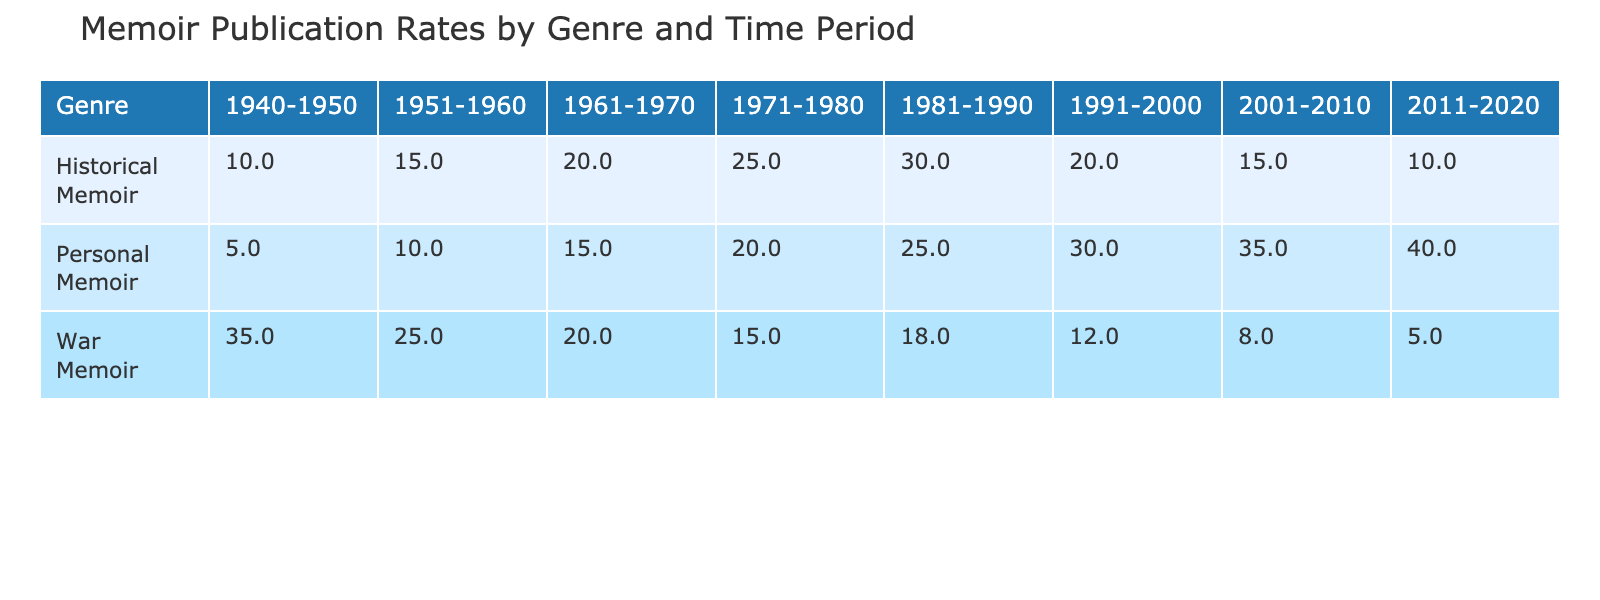What was the publication rate for War Memoirs in the 1940-1950 time period? The table shows the publication rate for War Memoirs from 1940-1950 is 35%.
Answer: 35% How did the publication rate for Historical Memoirs change from 1951-1960 to 1971-1980? The publication rate for Historical Memoirs in 1951-1960 is 15%, and in 1971-1980 it is 25%. The change is an increase of 10 percentage points.
Answer: Increased by 10% Is the publication rate for Personal Memoirs higher or lower in the 2001-2010 time period compared to 1940-1950? The publication rate for Personal Memoirs in 2001-2010 is 35%, while in 1940-1950 it is 5%. Therefore, it is higher in 2001-2010.
Answer: Higher What is the overall trend for War Memoirs over the decades? Observing the rates, War Memoirs see a decline from 1940-1950 (35%) to 2011-2020 (5%). This indicates a downward trend.
Answer: Downward trend What was the average publication rate for Historical Memoirs across all time periods? Adding the publication rates for Historical Memoirs across all periods (10, 15, 20, 25, 30, 20, 15, 10), we get 145. Dividing by 8 periods gives an average of 18.125%.
Answer: 18.125% Was the publication rate for the 1981-1990 period for Personal Memoirs greater than that of Historical Memoirs in the same period? The publication rate for Personal Memoirs in 1981-1990 is 25%, while for Historical Memoirs it's 30%. Since 25% is less than 30%, the answer is no.
Answer: No Which genre had the highest publication rate in the 1940-1950 time period? War Memoirs had a publication rate of 35%, which is higher than Historical Memoirs (10%) and Personal Memoirs (5%). Thus, War Memoirs had the highest rate in that period.
Answer: War Memoir What is the difference in publication rates between Personal Memoirs in 2011-2020 and War Memoirs in the same period? Personal Memoirs in 2011-2020 has a rate of 40%, while War Memoirs has a rate of 5%. The difference is 40% - 5% = 35%.
Answer: 35% In which time period was the publication rate for Historical Memoirs the lowest? The lowest publication rate for Historical Memoirs is 10%, which occurred in the 2011-2020 time period.
Answer: 2011-2020 